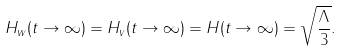<formula> <loc_0><loc_0><loc_500><loc_500>H _ { w } ( t \rightarrow \infty ) = H _ { v } ( t \rightarrow \infty ) = H ( t \rightarrow \infty ) = \sqrt { \frac { \Lambda } { 3 } } .</formula> 